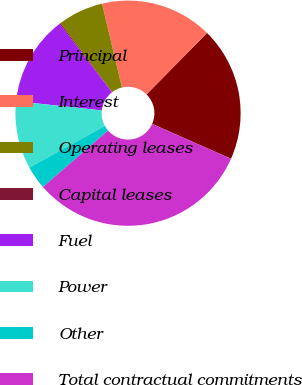Convert chart. <chart><loc_0><loc_0><loc_500><loc_500><pie_chart><fcel>Principal<fcel>Interest<fcel>Operating leases<fcel>Capital leases<fcel>Fuel<fcel>Power<fcel>Other<fcel>Total contractual commitments<nl><fcel>19.26%<fcel>16.08%<fcel>6.53%<fcel>0.17%<fcel>12.9%<fcel>9.72%<fcel>3.35%<fcel>31.99%<nl></chart> 